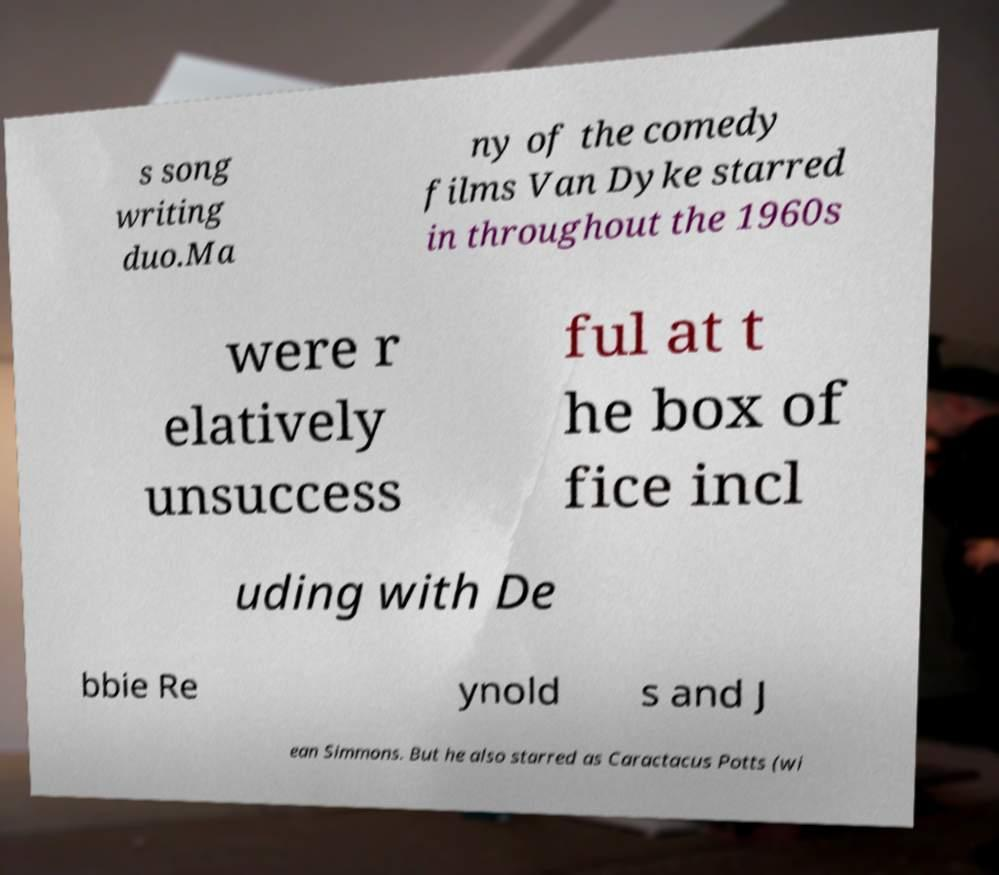Please identify and transcribe the text found in this image. s song writing duo.Ma ny of the comedy films Van Dyke starred in throughout the 1960s were r elatively unsuccess ful at t he box of fice incl uding with De bbie Re ynold s and J ean Simmons. But he also starred as Caractacus Potts (wi 